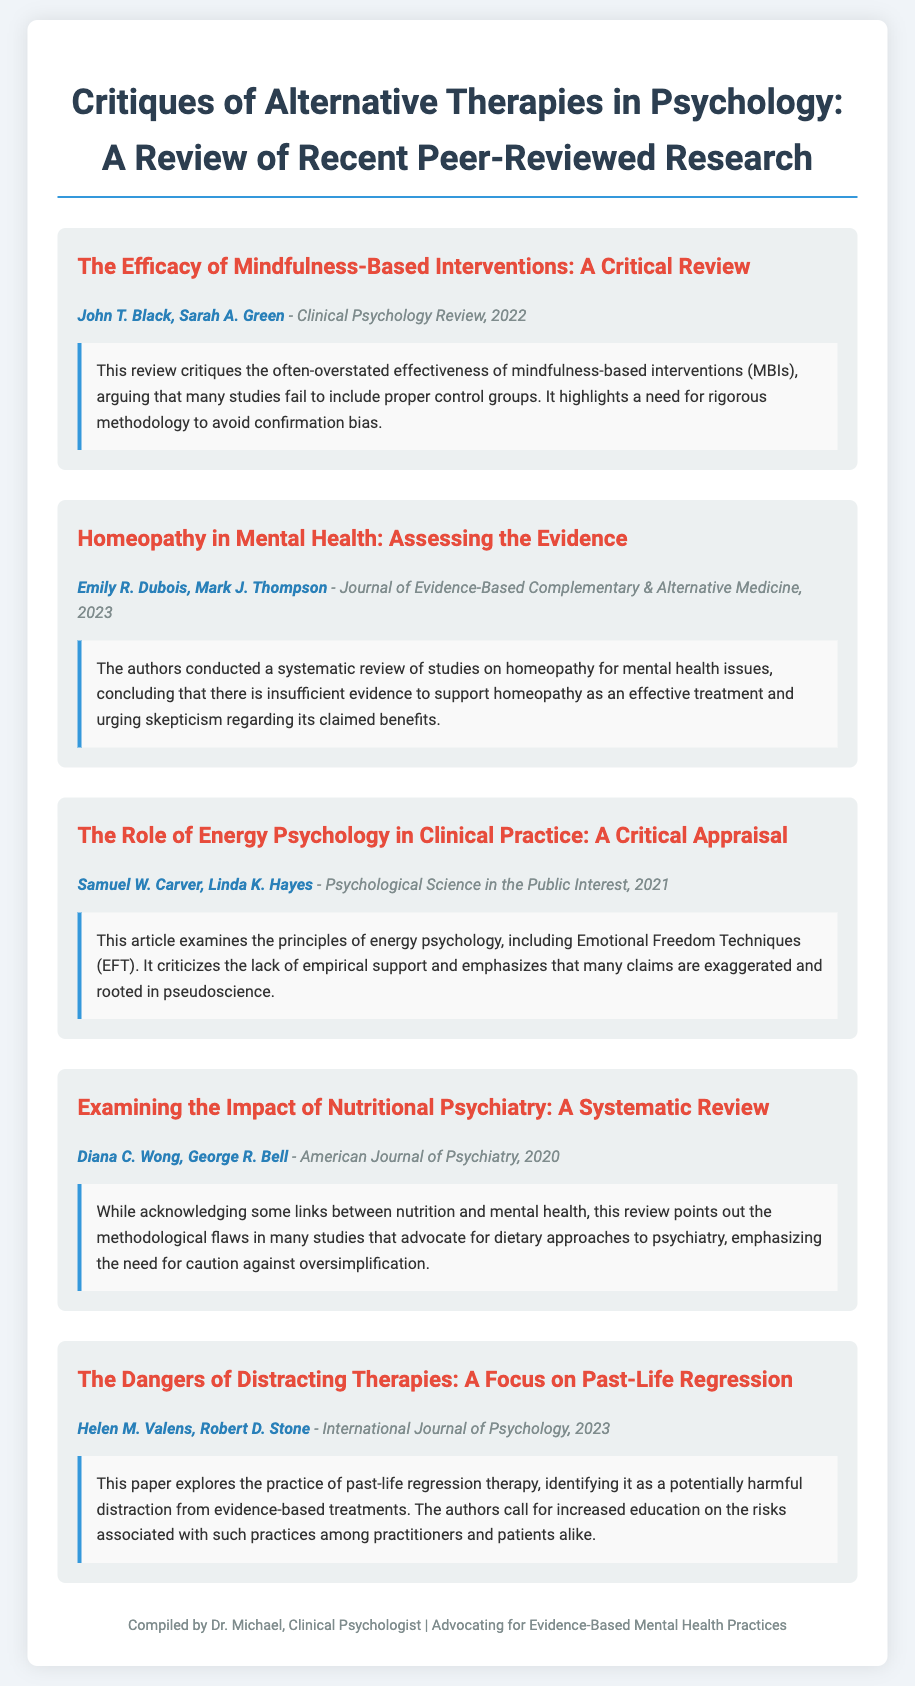What is the title of the article by John T. Black and Sarah A. Green? The title is stated at the beginning of the article section authored by John T. Black and Sarah A. Green.
Answer: The Efficacy of Mindfulness-Based Interventions: A Critical Review Who are the authors of the article assessing homeopathy in mental health? The authors are mentioned in the article's metadata section.
Answer: Emily R. Dubois, Mark J. Thompson In what year was the article on energy psychology published? The publication year is included in the article metadata for easy reference.
Answer: 2021 What is identified as potentially harmful in the article by Helen M. Valens and Robert D. Stone? The specific practice being critiqued is mentioned directly in the article’s findings.
Answer: Past-life regression therapy Which psychological intervention type is critiqued for methodological flaws in its nutritional aspects? This question requires synthesizing information from the relevant article on dietary practices in psychiatry.
Answer: Nutritional psychiatry What is a common theme in the critiques presented in the document? The themes can be derived from the summaries of all articles included in the note.
Answer: Lack of empirical support How many articles are summarized in this document? The number of articles can be counted from how many sections were created in the document.
Answer: Five 